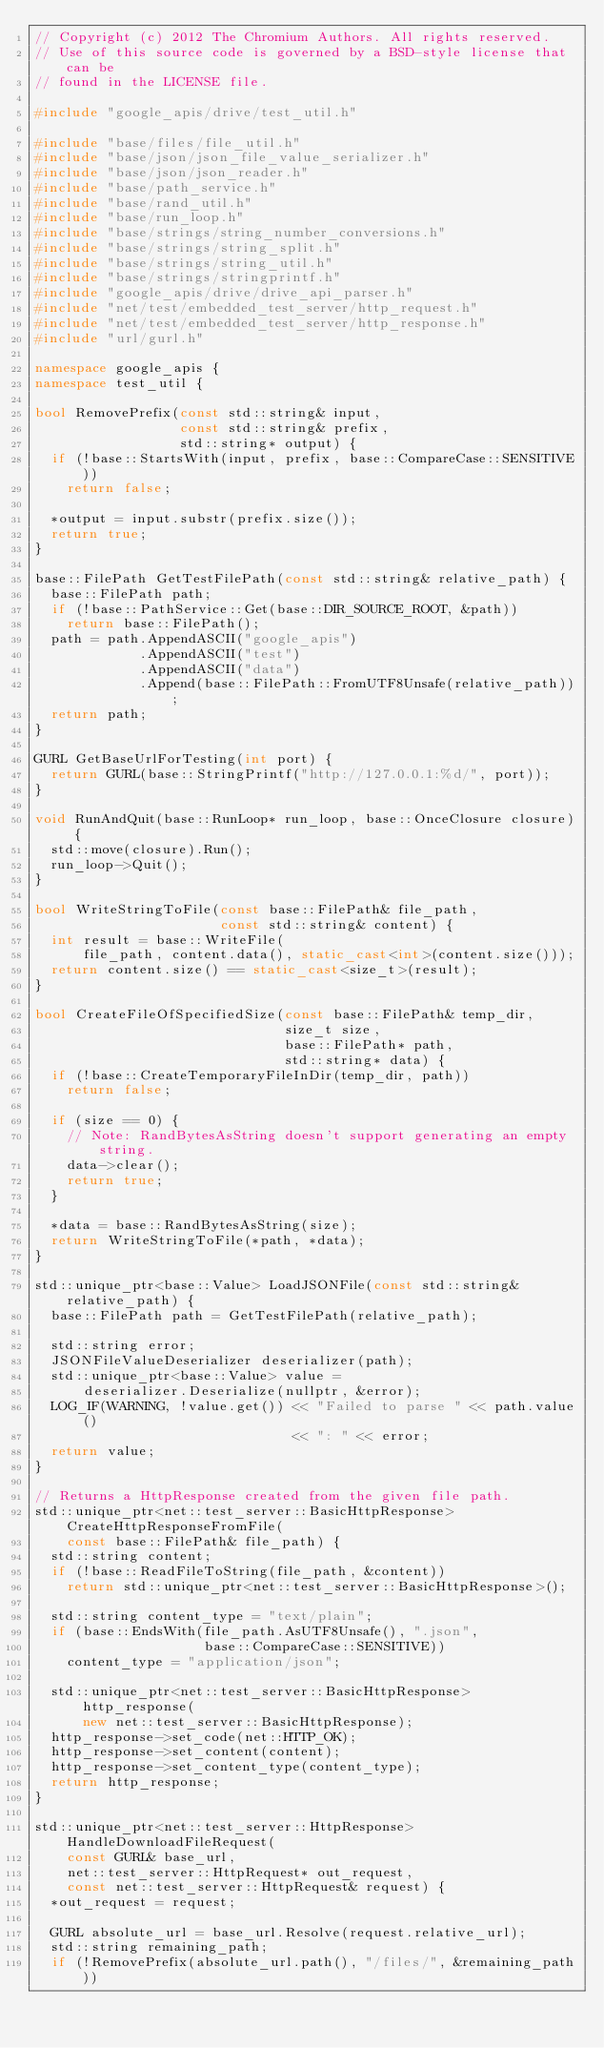<code> <loc_0><loc_0><loc_500><loc_500><_C++_>// Copyright (c) 2012 The Chromium Authors. All rights reserved.
// Use of this source code is governed by a BSD-style license that can be
// found in the LICENSE file.

#include "google_apis/drive/test_util.h"

#include "base/files/file_util.h"
#include "base/json/json_file_value_serializer.h"
#include "base/json/json_reader.h"
#include "base/path_service.h"
#include "base/rand_util.h"
#include "base/run_loop.h"
#include "base/strings/string_number_conversions.h"
#include "base/strings/string_split.h"
#include "base/strings/string_util.h"
#include "base/strings/stringprintf.h"
#include "google_apis/drive/drive_api_parser.h"
#include "net/test/embedded_test_server/http_request.h"
#include "net/test/embedded_test_server/http_response.h"
#include "url/gurl.h"

namespace google_apis {
namespace test_util {

bool RemovePrefix(const std::string& input,
                  const std::string& prefix,
                  std::string* output) {
  if (!base::StartsWith(input, prefix, base::CompareCase::SENSITIVE))
    return false;

  *output = input.substr(prefix.size());
  return true;
}

base::FilePath GetTestFilePath(const std::string& relative_path) {
  base::FilePath path;
  if (!base::PathService::Get(base::DIR_SOURCE_ROOT, &path))
    return base::FilePath();
  path = path.AppendASCII("google_apis")
             .AppendASCII("test")
             .AppendASCII("data")
             .Append(base::FilePath::FromUTF8Unsafe(relative_path));
  return path;
}

GURL GetBaseUrlForTesting(int port) {
  return GURL(base::StringPrintf("http://127.0.0.1:%d/", port));
}

void RunAndQuit(base::RunLoop* run_loop, base::OnceClosure closure) {
  std::move(closure).Run();
  run_loop->Quit();
}

bool WriteStringToFile(const base::FilePath& file_path,
                       const std::string& content) {
  int result = base::WriteFile(
      file_path, content.data(), static_cast<int>(content.size()));
  return content.size() == static_cast<size_t>(result);
}

bool CreateFileOfSpecifiedSize(const base::FilePath& temp_dir,
                               size_t size,
                               base::FilePath* path,
                               std::string* data) {
  if (!base::CreateTemporaryFileInDir(temp_dir, path))
    return false;

  if (size == 0) {
    // Note: RandBytesAsString doesn't support generating an empty string.
    data->clear();
    return true;
  }

  *data = base::RandBytesAsString(size);
  return WriteStringToFile(*path, *data);
}

std::unique_ptr<base::Value> LoadJSONFile(const std::string& relative_path) {
  base::FilePath path = GetTestFilePath(relative_path);

  std::string error;
  JSONFileValueDeserializer deserializer(path);
  std::unique_ptr<base::Value> value =
      deserializer.Deserialize(nullptr, &error);
  LOG_IF(WARNING, !value.get()) << "Failed to parse " << path.value()
                                << ": " << error;
  return value;
}

// Returns a HttpResponse created from the given file path.
std::unique_ptr<net::test_server::BasicHttpResponse> CreateHttpResponseFromFile(
    const base::FilePath& file_path) {
  std::string content;
  if (!base::ReadFileToString(file_path, &content))
    return std::unique_ptr<net::test_server::BasicHttpResponse>();

  std::string content_type = "text/plain";
  if (base::EndsWith(file_path.AsUTF8Unsafe(), ".json",
                     base::CompareCase::SENSITIVE))
    content_type = "application/json";

  std::unique_ptr<net::test_server::BasicHttpResponse> http_response(
      new net::test_server::BasicHttpResponse);
  http_response->set_code(net::HTTP_OK);
  http_response->set_content(content);
  http_response->set_content_type(content_type);
  return http_response;
}

std::unique_ptr<net::test_server::HttpResponse> HandleDownloadFileRequest(
    const GURL& base_url,
    net::test_server::HttpRequest* out_request,
    const net::test_server::HttpRequest& request) {
  *out_request = request;

  GURL absolute_url = base_url.Resolve(request.relative_url);
  std::string remaining_path;
  if (!RemovePrefix(absolute_url.path(), "/files/", &remaining_path))</code> 